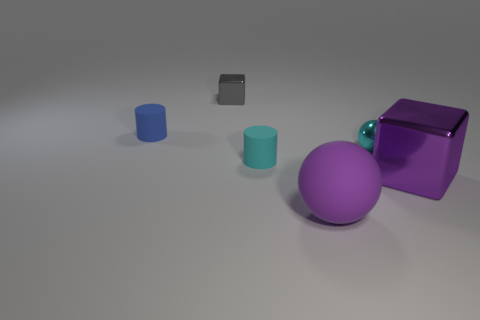What shape is the small cyan object that is the same material as the large purple ball?
Offer a terse response. Cylinder. Is there anything else that has the same shape as the gray metallic thing?
Ensure brevity in your answer.  Yes. What color is the object that is both in front of the small cyan metallic ball and on the right side of the rubber ball?
Make the answer very short. Purple. How many balls are metallic things or small rubber things?
Ensure brevity in your answer.  1. How many things have the same size as the blue cylinder?
Your answer should be compact. 3. How many small spheres are on the left side of the sphere behind the large matte ball?
Give a very brief answer. 0. There is a rubber object that is on the left side of the big purple rubber thing and in front of the blue cylinder; what size is it?
Your response must be concise. Small. Are there more purple rubber objects than yellow metallic cylinders?
Ensure brevity in your answer.  Yes. Are there any shiny things that have the same color as the large ball?
Your answer should be very brief. Yes. There is a purple metallic block behind the purple ball; does it have the same size as the large purple matte sphere?
Your answer should be compact. Yes. 